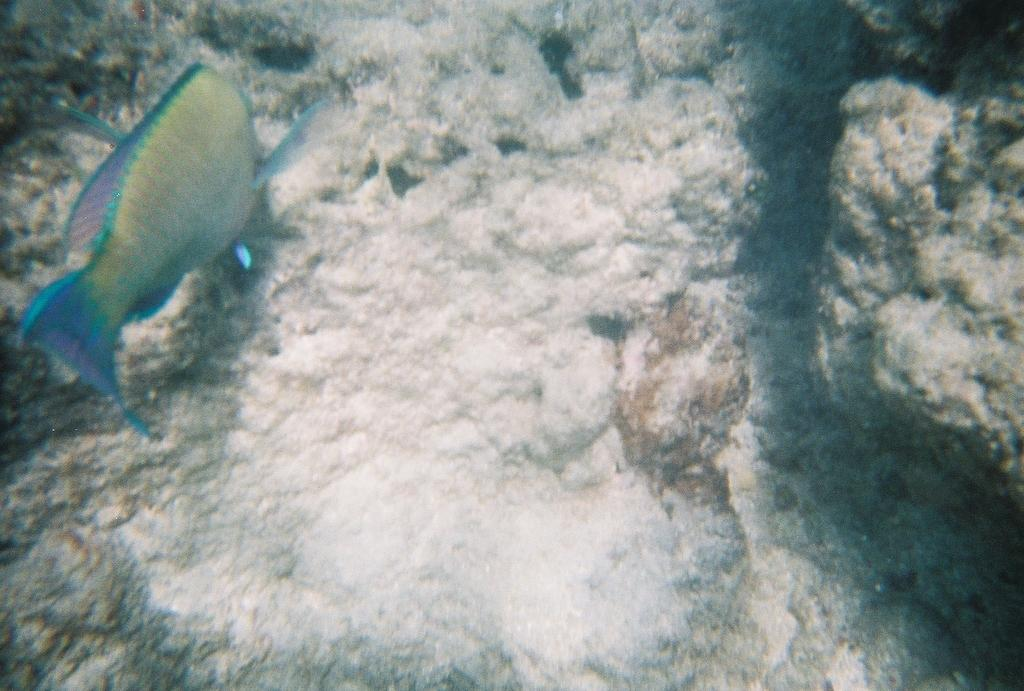What is located under the water in the image? There is a fish under the water in the image. What can be seen on the stones in the image? There is a white color object on the stones in the image. Can you tell me what type of owl is sitting on the fish in the image? There is no owl present in the image; it features a fish under the water and a white object on the stones. What design is featured on the dinner plate in the image? There is no dinner plate present in the image. 